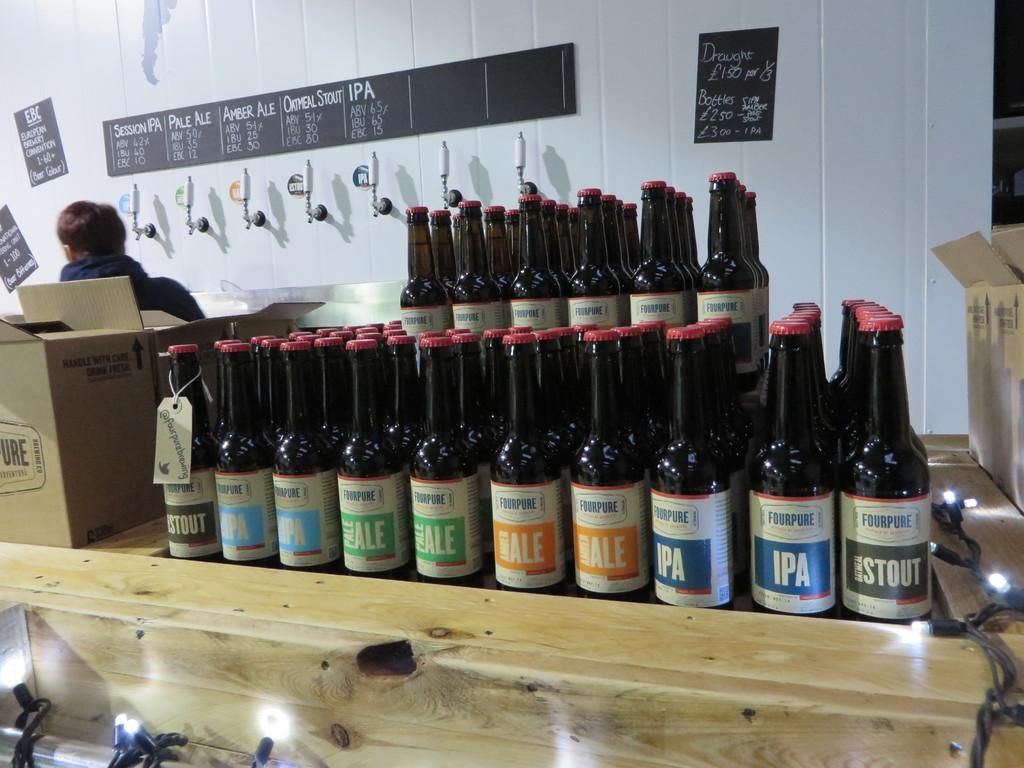Provide a one-sentence caption for the provided image. A stack of IPA and ale bottles rest on a counter. 